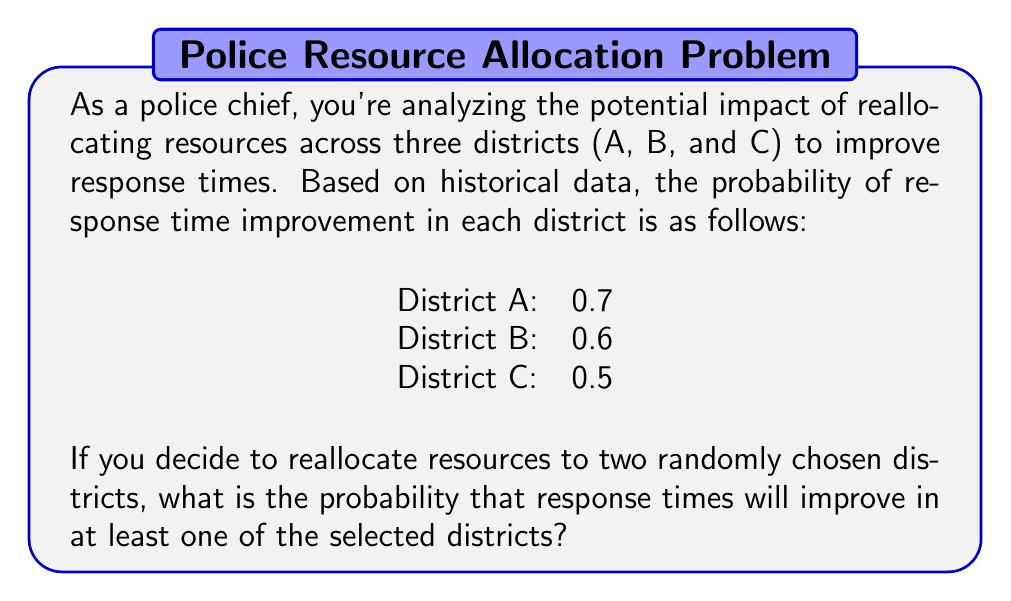Could you help me with this problem? Let's approach this step-by-step:

1) First, we need to calculate the probability of selecting any two districts out of the three. There are three possible combinations: (A,B), (A,C), and (B,C). Each combination has an equal probability of $\frac{1}{3}$.

2) Now, let's calculate the probability of improvement for each combination:

   For (A,B):
   P(at least one improves) = 1 - P(neither improves)
   $$ P(A,B) = 1 - (1-0.7)(1-0.6) = 1 - 0.3 \times 0.4 = 1 - 0.12 = 0.88 $$

   For (A,C):
   $$ P(A,C) = 1 - (1-0.7)(1-0.5) = 1 - 0.3 \times 0.5 = 1 - 0.15 = 0.85 $$

   For (B,C):
   $$ P(B,C) = 1 - (1-0.6)(1-0.5) = 1 - 0.4 \times 0.5 = 1 - 0.20 = 0.80 $$

3) The overall probability is the weighted average of these probabilities:

   $$ P(\text{improvement}) = \frac{1}{3} \times 0.88 + \frac{1}{3} \times 0.85 + \frac{1}{3} \times 0.80 $$

4) Simplifying:

   $$ P(\text{improvement}) = \frac{0.88 + 0.85 + 0.80}{3} = \frac{2.53}{3} \approx 0.8433 $$

Therefore, the probability that response times will improve in at least one of the selected districts is approximately 0.8433 or 84.33%.
Answer: The probability that response times will improve in at least one of the two randomly selected districts is approximately 0.8433 or 84.33%. 